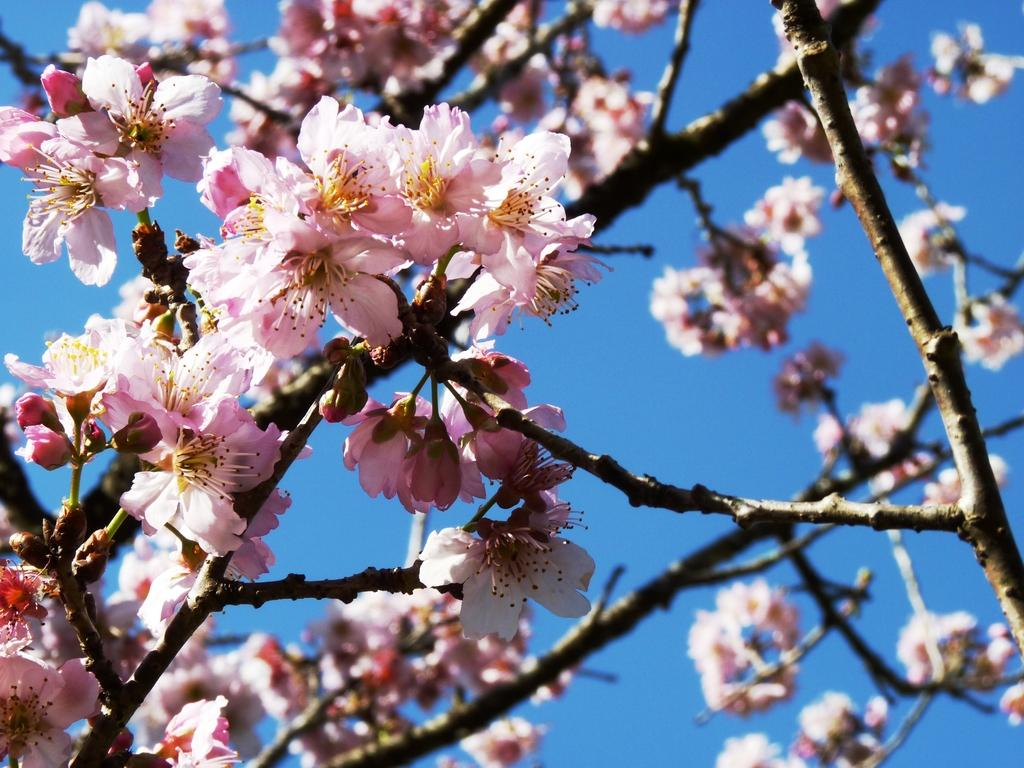What type of plant life is visible in the image? There are stems with flowers and buds in the image. What can be seen in the background of the image? The background of the image includes the sky. What position does the brick hold in the image? There is no brick present in the image. 